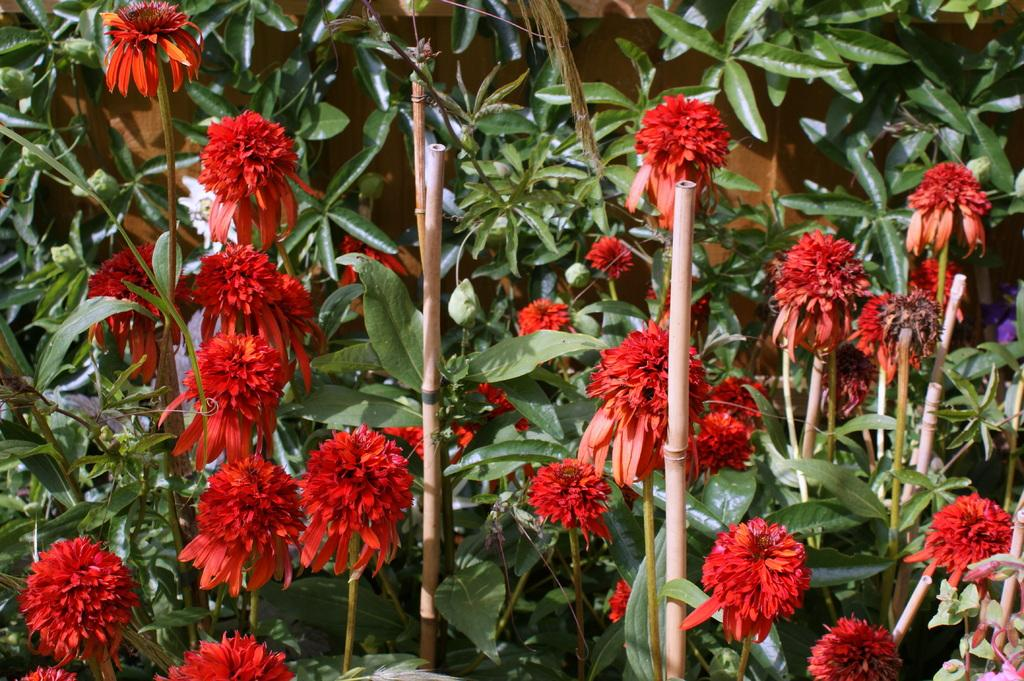What type of plants are visible in the image? There are plants with flowers in the image. What material are the sticks made of in the image? A: The sticks in the image are made of wood. What type of street is visible in the image? There is no street present in the image; it features plants with flowers and wooden sticks. What kind of trouble can be seen in the image? There is no trouble depicted in the image; it shows plants with flowers and wooden sticks. 